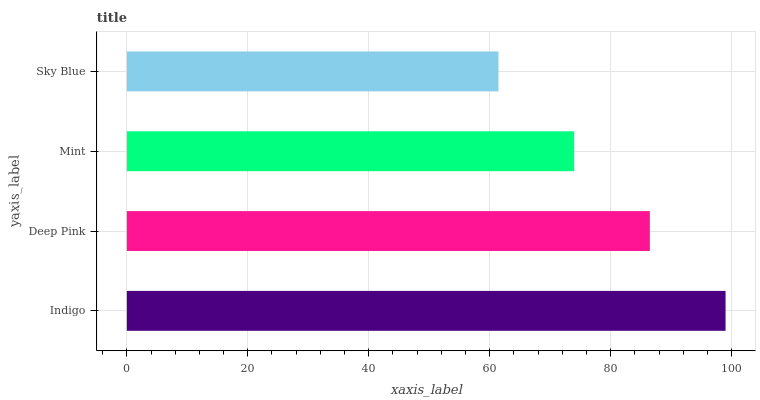Is Sky Blue the minimum?
Answer yes or no. Yes. Is Indigo the maximum?
Answer yes or no. Yes. Is Deep Pink the minimum?
Answer yes or no. No. Is Deep Pink the maximum?
Answer yes or no. No. Is Indigo greater than Deep Pink?
Answer yes or no. Yes. Is Deep Pink less than Indigo?
Answer yes or no. Yes. Is Deep Pink greater than Indigo?
Answer yes or no. No. Is Indigo less than Deep Pink?
Answer yes or no. No. Is Deep Pink the high median?
Answer yes or no. Yes. Is Mint the low median?
Answer yes or no. Yes. Is Mint the high median?
Answer yes or no. No. Is Sky Blue the low median?
Answer yes or no. No. 